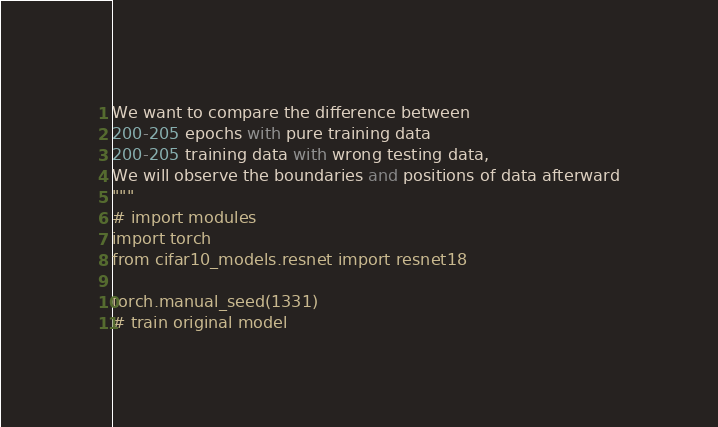Convert code to text. <code><loc_0><loc_0><loc_500><loc_500><_Python_>We want to compare the difference between
200-205 epochs with pure training data
200-205 training data with wrong testing data,
We will observe the boundaries and positions of data afterward
"""
# import modules
import torch
from cifar10_models.resnet import resnet18

torch.manual_seed(1331)
# train original model
</code> 